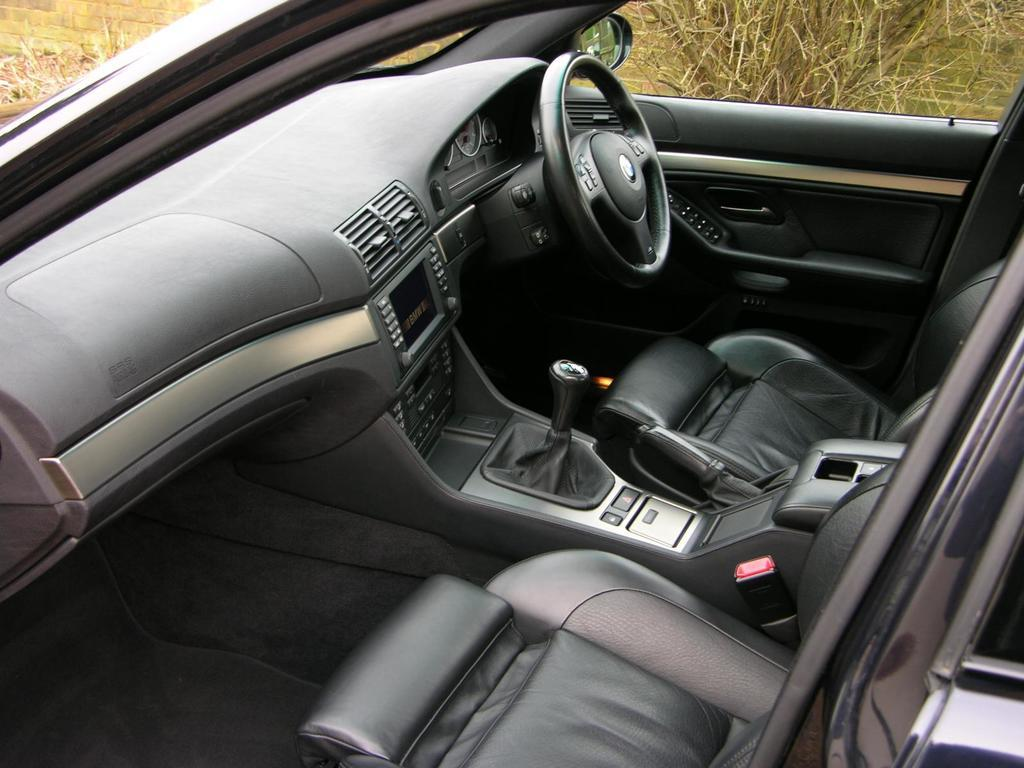What type of vehicle is shown in the image? The image shows the interior of a car. What is the main control device visible in the image? There is a steering wheel visible in the image. What color are the seats in the car? The seats in the car are black. What can be seen in the background of the image? The background of the image includes dried grass. What is the color of the grass in the image? The grass is brown in color. Can you tell me how many times the sheet is folded in the image? There is no sheet present in the image; it shows the interior of a car. What type of act is being performed by the driver in the image? There is no driver visible in the image, and no act is being performed. 